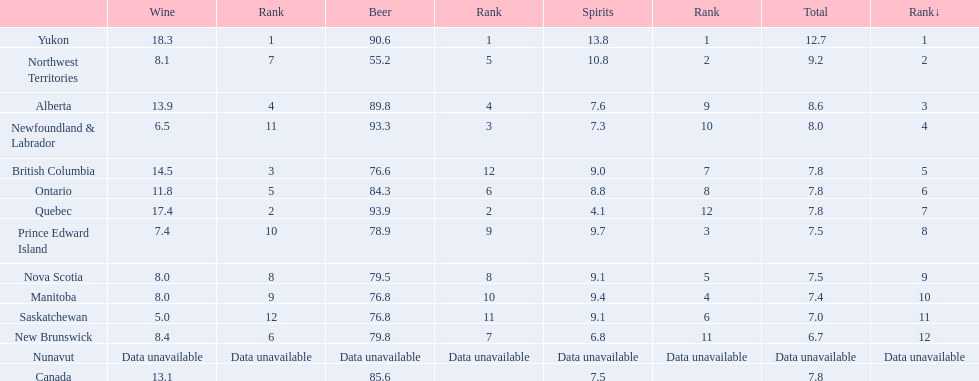In canada, which territory had a beer consumption rate of 93.9? Quebec. What was the corresponding consumption rate for spirits in that territory? 4.1. 